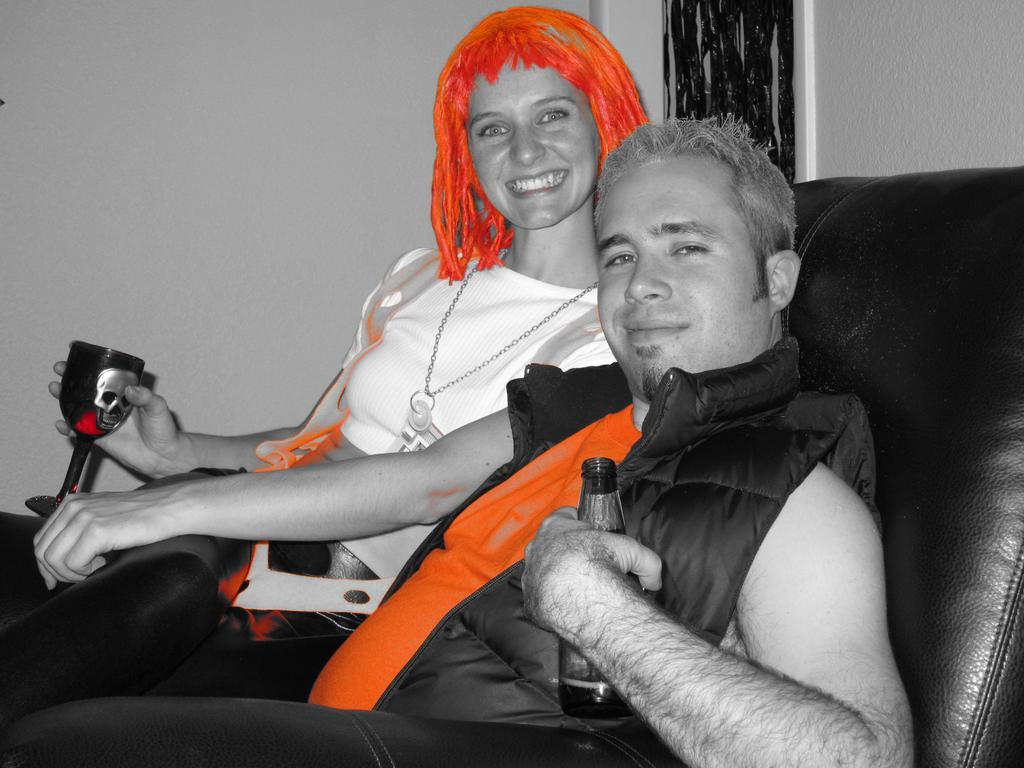How many people are in the image? There are two people in the image. What are the people doing in the image? The people are sitting on a sofa. What are the people holding in the image? The people are holding objects. What can be seen in the background of the image? There is a grill and a wall in the background of the image. What type of popcorn is being served to the mom in the image? There is no mom present in the image, nor is there any popcorn visible. 